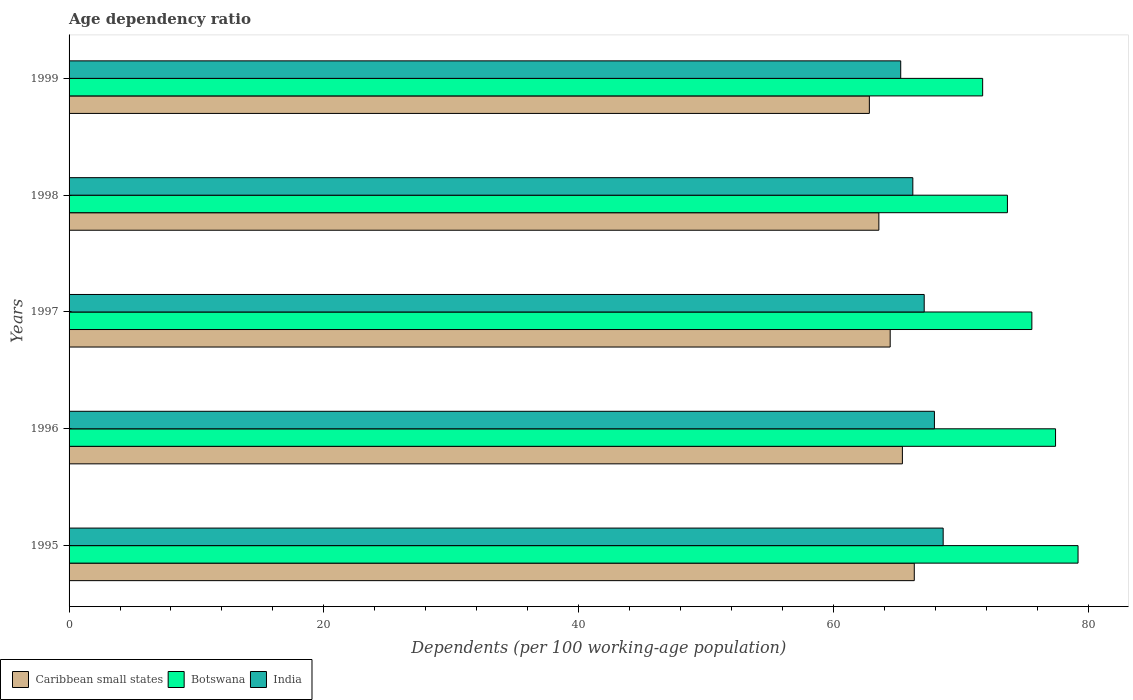How many groups of bars are there?
Keep it short and to the point. 5. Are the number of bars per tick equal to the number of legend labels?
Keep it short and to the point. Yes. What is the label of the 5th group of bars from the top?
Make the answer very short. 1995. In how many cases, is the number of bars for a given year not equal to the number of legend labels?
Provide a succinct answer. 0. What is the age dependency ratio in in Caribbean small states in 1997?
Your response must be concise. 64.46. Across all years, what is the maximum age dependency ratio in in Caribbean small states?
Offer a terse response. 66.36. Across all years, what is the minimum age dependency ratio in in Botswana?
Give a very brief answer. 71.72. In which year was the age dependency ratio in in India minimum?
Offer a terse response. 1999. What is the total age dependency ratio in in Botswana in the graph?
Provide a succinct answer. 377.64. What is the difference between the age dependency ratio in in Caribbean small states in 1995 and that in 1997?
Provide a short and direct response. 1.89. What is the difference between the age dependency ratio in in Caribbean small states in 1996 and the age dependency ratio in in Botswana in 1997?
Ensure brevity in your answer.  -10.16. What is the average age dependency ratio in in Botswana per year?
Your answer should be compact. 75.53. In the year 1998, what is the difference between the age dependency ratio in in Caribbean small states and age dependency ratio in in Botswana?
Ensure brevity in your answer.  -10.09. What is the ratio of the age dependency ratio in in Botswana in 1995 to that in 1999?
Provide a succinct answer. 1.1. Is the age dependency ratio in in Caribbean small states in 1995 less than that in 1997?
Offer a terse response. No. Is the difference between the age dependency ratio in in Caribbean small states in 1995 and 1998 greater than the difference between the age dependency ratio in in Botswana in 1995 and 1998?
Keep it short and to the point. No. What is the difference between the highest and the second highest age dependency ratio in in Botswana?
Your response must be concise. 1.77. What is the difference between the highest and the lowest age dependency ratio in in Botswana?
Keep it short and to the point. 7.49. What does the 1st bar from the top in 1996 represents?
Make the answer very short. India. What does the 3rd bar from the bottom in 1996 represents?
Provide a succinct answer. India. Is it the case that in every year, the sum of the age dependency ratio in in Caribbean small states and age dependency ratio in in Botswana is greater than the age dependency ratio in in India?
Give a very brief answer. Yes. How many bars are there?
Offer a very short reply. 15. How many years are there in the graph?
Provide a short and direct response. 5. What is the difference between two consecutive major ticks on the X-axis?
Your answer should be compact. 20. Are the values on the major ticks of X-axis written in scientific E-notation?
Your response must be concise. No. Does the graph contain any zero values?
Ensure brevity in your answer.  No. Where does the legend appear in the graph?
Offer a very short reply. Bottom left. How many legend labels are there?
Your answer should be very brief. 3. How are the legend labels stacked?
Your response must be concise. Horizontal. What is the title of the graph?
Give a very brief answer. Age dependency ratio. Does "Uzbekistan" appear as one of the legend labels in the graph?
Provide a succinct answer. No. What is the label or title of the X-axis?
Provide a short and direct response. Dependents (per 100 working-age population). What is the Dependents (per 100 working-age population) of Caribbean small states in 1995?
Your response must be concise. 66.36. What is the Dependents (per 100 working-age population) of Botswana in 1995?
Keep it short and to the point. 79.21. What is the Dependents (per 100 working-age population) in India in 1995?
Offer a very short reply. 68.62. What is the Dependents (per 100 working-age population) in Caribbean small states in 1996?
Keep it short and to the point. 65.42. What is the Dependents (per 100 working-age population) in Botswana in 1996?
Offer a very short reply. 77.45. What is the Dependents (per 100 working-age population) of India in 1996?
Offer a very short reply. 67.94. What is the Dependents (per 100 working-age population) in Caribbean small states in 1997?
Your answer should be very brief. 64.46. What is the Dependents (per 100 working-age population) in Botswana in 1997?
Your answer should be compact. 75.59. What is the Dependents (per 100 working-age population) of India in 1997?
Your answer should be very brief. 67.13. What is the Dependents (per 100 working-age population) of Caribbean small states in 1998?
Offer a very short reply. 63.57. What is the Dependents (per 100 working-age population) in Botswana in 1998?
Offer a very short reply. 73.67. What is the Dependents (per 100 working-age population) in India in 1998?
Your response must be concise. 66.24. What is the Dependents (per 100 working-age population) of Caribbean small states in 1999?
Provide a short and direct response. 62.83. What is the Dependents (per 100 working-age population) of Botswana in 1999?
Make the answer very short. 71.72. What is the Dependents (per 100 working-age population) of India in 1999?
Keep it short and to the point. 65.29. Across all years, what is the maximum Dependents (per 100 working-age population) of Caribbean small states?
Give a very brief answer. 66.36. Across all years, what is the maximum Dependents (per 100 working-age population) of Botswana?
Provide a succinct answer. 79.21. Across all years, what is the maximum Dependents (per 100 working-age population) of India?
Make the answer very short. 68.62. Across all years, what is the minimum Dependents (per 100 working-age population) of Caribbean small states?
Offer a terse response. 62.83. Across all years, what is the minimum Dependents (per 100 working-age population) of Botswana?
Offer a very short reply. 71.72. Across all years, what is the minimum Dependents (per 100 working-age population) in India?
Offer a terse response. 65.29. What is the total Dependents (per 100 working-age population) of Caribbean small states in the graph?
Ensure brevity in your answer.  322.64. What is the total Dependents (per 100 working-age population) in Botswana in the graph?
Your answer should be very brief. 377.64. What is the total Dependents (per 100 working-age population) in India in the graph?
Make the answer very short. 335.23. What is the difference between the Dependents (per 100 working-age population) of Caribbean small states in 1995 and that in 1996?
Your answer should be compact. 0.93. What is the difference between the Dependents (per 100 working-age population) of Botswana in 1995 and that in 1996?
Provide a short and direct response. 1.77. What is the difference between the Dependents (per 100 working-age population) in India in 1995 and that in 1996?
Give a very brief answer. 0.69. What is the difference between the Dependents (per 100 working-age population) in Caribbean small states in 1995 and that in 1997?
Ensure brevity in your answer.  1.89. What is the difference between the Dependents (per 100 working-age population) of Botswana in 1995 and that in 1997?
Your answer should be compact. 3.63. What is the difference between the Dependents (per 100 working-age population) in India in 1995 and that in 1997?
Offer a terse response. 1.49. What is the difference between the Dependents (per 100 working-age population) in Caribbean small states in 1995 and that in 1998?
Make the answer very short. 2.78. What is the difference between the Dependents (per 100 working-age population) in Botswana in 1995 and that in 1998?
Provide a succinct answer. 5.54. What is the difference between the Dependents (per 100 working-age population) of India in 1995 and that in 1998?
Keep it short and to the point. 2.38. What is the difference between the Dependents (per 100 working-age population) of Caribbean small states in 1995 and that in 1999?
Your response must be concise. 3.53. What is the difference between the Dependents (per 100 working-age population) of Botswana in 1995 and that in 1999?
Provide a short and direct response. 7.49. What is the difference between the Dependents (per 100 working-age population) in India in 1995 and that in 1999?
Provide a succinct answer. 3.33. What is the difference between the Dependents (per 100 working-age population) in Caribbean small states in 1996 and that in 1997?
Offer a terse response. 0.96. What is the difference between the Dependents (per 100 working-age population) in Botswana in 1996 and that in 1997?
Provide a succinct answer. 1.86. What is the difference between the Dependents (per 100 working-age population) in India in 1996 and that in 1997?
Keep it short and to the point. 0.8. What is the difference between the Dependents (per 100 working-age population) of Caribbean small states in 1996 and that in 1998?
Make the answer very short. 1.85. What is the difference between the Dependents (per 100 working-age population) in Botswana in 1996 and that in 1998?
Your response must be concise. 3.78. What is the difference between the Dependents (per 100 working-age population) in India in 1996 and that in 1998?
Offer a very short reply. 1.7. What is the difference between the Dependents (per 100 working-age population) of Caribbean small states in 1996 and that in 1999?
Ensure brevity in your answer.  2.59. What is the difference between the Dependents (per 100 working-age population) in Botswana in 1996 and that in 1999?
Offer a very short reply. 5.72. What is the difference between the Dependents (per 100 working-age population) in India in 1996 and that in 1999?
Offer a very short reply. 2.65. What is the difference between the Dependents (per 100 working-age population) in Caribbean small states in 1997 and that in 1998?
Ensure brevity in your answer.  0.89. What is the difference between the Dependents (per 100 working-age population) of Botswana in 1997 and that in 1998?
Offer a very short reply. 1.92. What is the difference between the Dependents (per 100 working-age population) in India in 1997 and that in 1998?
Provide a short and direct response. 0.89. What is the difference between the Dependents (per 100 working-age population) in Caribbean small states in 1997 and that in 1999?
Provide a short and direct response. 1.64. What is the difference between the Dependents (per 100 working-age population) in Botswana in 1997 and that in 1999?
Offer a very short reply. 3.86. What is the difference between the Dependents (per 100 working-age population) in India in 1997 and that in 1999?
Provide a succinct answer. 1.84. What is the difference between the Dependents (per 100 working-age population) in Caribbean small states in 1998 and that in 1999?
Your answer should be compact. 0.75. What is the difference between the Dependents (per 100 working-age population) of Botswana in 1998 and that in 1999?
Provide a short and direct response. 1.94. What is the difference between the Dependents (per 100 working-age population) of India in 1998 and that in 1999?
Provide a succinct answer. 0.95. What is the difference between the Dependents (per 100 working-age population) in Caribbean small states in 1995 and the Dependents (per 100 working-age population) in Botswana in 1996?
Your answer should be very brief. -11.09. What is the difference between the Dependents (per 100 working-age population) in Caribbean small states in 1995 and the Dependents (per 100 working-age population) in India in 1996?
Ensure brevity in your answer.  -1.58. What is the difference between the Dependents (per 100 working-age population) of Botswana in 1995 and the Dependents (per 100 working-age population) of India in 1996?
Ensure brevity in your answer.  11.28. What is the difference between the Dependents (per 100 working-age population) of Caribbean small states in 1995 and the Dependents (per 100 working-age population) of Botswana in 1997?
Your response must be concise. -9.23. What is the difference between the Dependents (per 100 working-age population) in Caribbean small states in 1995 and the Dependents (per 100 working-age population) in India in 1997?
Keep it short and to the point. -0.78. What is the difference between the Dependents (per 100 working-age population) in Botswana in 1995 and the Dependents (per 100 working-age population) in India in 1997?
Provide a succinct answer. 12.08. What is the difference between the Dependents (per 100 working-age population) in Caribbean small states in 1995 and the Dependents (per 100 working-age population) in Botswana in 1998?
Your answer should be very brief. -7.31. What is the difference between the Dependents (per 100 working-age population) in Caribbean small states in 1995 and the Dependents (per 100 working-age population) in India in 1998?
Your answer should be very brief. 0.11. What is the difference between the Dependents (per 100 working-age population) of Botswana in 1995 and the Dependents (per 100 working-age population) of India in 1998?
Provide a succinct answer. 12.97. What is the difference between the Dependents (per 100 working-age population) in Caribbean small states in 1995 and the Dependents (per 100 working-age population) in Botswana in 1999?
Your answer should be very brief. -5.37. What is the difference between the Dependents (per 100 working-age population) of Caribbean small states in 1995 and the Dependents (per 100 working-age population) of India in 1999?
Make the answer very short. 1.07. What is the difference between the Dependents (per 100 working-age population) in Botswana in 1995 and the Dependents (per 100 working-age population) in India in 1999?
Your answer should be very brief. 13.92. What is the difference between the Dependents (per 100 working-age population) in Caribbean small states in 1996 and the Dependents (per 100 working-age population) in Botswana in 1997?
Your response must be concise. -10.16. What is the difference between the Dependents (per 100 working-age population) in Caribbean small states in 1996 and the Dependents (per 100 working-age population) in India in 1997?
Offer a terse response. -1.71. What is the difference between the Dependents (per 100 working-age population) in Botswana in 1996 and the Dependents (per 100 working-age population) in India in 1997?
Provide a short and direct response. 10.31. What is the difference between the Dependents (per 100 working-age population) in Caribbean small states in 1996 and the Dependents (per 100 working-age population) in Botswana in 1998?
Ensure brevity in your answer.  -8.25. What is the difference between the Dependents (per 100 working-age population) in Caribbean small states in 1996 and the Dependents (per 100 working-age population) in India in 1998?
Make the answer very short. -0.82. What is the difference between the Dependents (per 100 working-age population) in Botswana in 1996 and the Dependents (per 100 working-age population) in India in 1998?
Keep it short and to the point. 11.21. What is the difference between the Dependents (per 100 working-age population) of Caribbean small states in 1996 and the Dependents (per 100 working-age population) of Botswana in 1999?
Your response must be concise. -6.3. What is the difference between the Dependents (per 100 working-age population) in Caribbean small states in 1996 and the Dependents (per 100 working-age population) in India in 1999?
Provide a short and direct response. 0.13. What is the difference between the Dependents (per 100 working-age population) in Botswana in 1996 and the Dependents (per 100 working-age population) in India in 1999?
Your answer should be compact. 12.16. What is the difference between the Dependents (per 100 working-age population) of Caribbean small states in 1997 and the Dependents (per 100 working-age population) of Botswana in 1998?
Offer a very short reply. -9.2. What is the difference between the Dependents (per 100 working-age population) in Caribbean small states in 1997 and the Dependents (per 100 working-age population) in India in 1998?
Make the answer very short. -1.78. What is the difference between the Dependents (per 100 working-age population) of Botswana in 1997 and the Dependents (per 100 working-age population) of India in 1998?
Keep it short and to the point. 9.35. What is the difference between the Dependents (per 100 working-age population) of Caribbean small states in 1997 and the Dependents (per 100 working-age population) of Botswana in 1999?
Your response must be concise. -7.26. What is the difference between the Dependents (per 100 working-age population) of Caribbean small states in 1997 and the Dependents (per 100 working-age population) of India in 1999?
Keep it short and to the point. -0.83. What is the difference between the Dependents (per 100 working-age population) of Botswana in 1997 and the Dependents (per 100 working-age population) of India in 1999?
Offer a very short reply. 10.3. What is the difference between the Dependents (per 100 working-age population) in Caribbean small states in 1998 and the Dependents (per 100 working-age population) in Botswana in 1999?
Your response must be concise. -8.15. What is the difference between the Dependents (per 100 working-age population) in Caribbean small states in 1998 and the Dependents (per 100 working-age population) in India in 1999?
Ensure brevity in your answer.  -1.72. What is the difference between the Dependents (per 100 working-age population) in Botswana in 1998 and the Dependents (per 100 working-age population) in India in 1999?
Provide a succinct answer. 8.38. What is the average Dependents (per 100 working-age population) in Caribbean small states per year?
Your response must be concise. 64.53. What is the average Dependents (per 100 working-age population) in Botswana per year?
Ensure brevity in your answer.  75.53. What is the average Dependents (per 100 working-age population) in India per year?
Make the answer very short. 67.05. In the year 1995, what is the difference between the Dependents (per 100 working-age population) of Caribbean small states and Dependents (per 100 working-age population) of Botswana?
Provide a short and direct response. -12.86. In the year 1995, what is the difference between the Dependents (per 100 working-age population) in Caribbean small states and Dependents (per 100 working-age population) in India?
Provide a succinct answer. -2.27. In the year 1995, what is the difference between the Dependents (per 100 working-age population) in Botswana and Dependents (per 100 working-age population) in India?
Give a very brief answer. 10.59. In the year 1996, what is the difference between the Dependents (per 100 working-age population) in Caribbean small states and Dependents (per 100 working-age population) in Botswana?
Your response must be concise. -12.02. In the year 1996, what is the difference between the Dependents (per 100 working-age population) in Caribbean small states and Dependents (per 100 working-age population) in India?
Make the answer very short. -2.51. In the year 1996, what is the difference between the Dependents (per 100 working-age population) in Botswana and Dependents (per 100 working-age population) in India?
Make the answer very short. 9.51. In the year 1997, what is the difference between the Dependents (per 100 working-age population) of Caribbean small states and Dependents (per 100 working-age population) of Botswana?
Ensure brevity in your answer.  -11.12. In the year 1997, what is the difference between the Dependents (per 100 working-age population) of Caribbean small states and Dependents (per 100 working-age population) of India?
Your answer should be very brief. -2.67. In the year 1997, what is the difference between the Dependents (per 100 working-age population) of Botswana and Dependents (per 100 working-age population) of India?
Your answer should be very brief. 8.45. In the year 1998, what is the difference between the Dependents (per 100 working-age population) in Caribbean small states and Dependents (per 100 working-age population) in Botswana?
Ensure brevity in your answer.  -10.09. In the year 1998, what is the difference between the Dependents (per 100 working-age population) of Caribbean small states and Dependents (per 100 working-age population) of India?
Your answer should be very brief. -2.67. In the year 1998, what is the difference between the Dependents (per 100 working-age population) of Botswana and Dependents (per 100 working-age population) of India?
Your answer should be very brief. 7.43. In the year 1999, what is the difference between the Dependents (per 100 working-age population) of Caribbean small states and Dependents (per 100 working-age population) of Botswana?
Ensure brevity in your answer.  -8.9. In the year 1999, what is the difference between the Dependents (per 100 working-age population) in Caribbean small states and Dependents (per 100 working-age population) in India?
Your answer should be very brief. -2.46. In the year 1999, what is the difference between the Dependents (per 100 working-age population) of Botswana and Dependents (per 100 working-age population) of India?
Ensure brevity in your answer.  6.43. What is the ratio of the Dependents (per 100 working-age population) of Caribbean small states in 1995 to that in 1996?
Make the answer very short. 1.01. What is the ratio of the Dependents (per 100 working-age population) of Botswana in 1995 to that in 1996?
Keep it short and to the point. 1.02. What is the ratio of the Dependents (per 100 working-age population) in Caribbean small states in 1995 to that in 1997?
Provide a succinct answer. 1.03. What is the ratio of the Dependents (per 100 working-age population) of Botswana in 1995 to that in 1997?
Provide a succinct answer. 1.05. What is the ratio of the Dependents (per 100 working-age population) of India in 1995 to that in 1997?
Provide a short and direct response. 1.02. What is the ratio of the Dependents (per 100 working-age population) of Caribbean small states in 1995 to that in 1998?
Provide a short and direct response. 1.04. What is the ratio of the Dependents (per 100 working-age population) of Botswana in 1995 to that in 1998?
Your answer should be compact. 1.08. What is the ratio of the Dependents (per 100 working-age population) in India in 1995 to that in 1998?
Make the answer very short. 1.04. What is the ratio of the Dependents (per 100 working-age population) of Caribbean small states in 1995 to that in 1999?
Offer a terse response. 1.06. What is the ratio of the Dependents (per 100 working-age population) of Botswana in 1995 to that in 1999?
Offer a very short reply. 1.1. What is the ratio of the Dependents (per 100 working-age population) of India in 1995 to that in 1999?
Your answer should be very brief. 1.05. What is the ratio of the Dependents (per 100 working-age population) of Caribbean small states in 1996 to that in 1997?
Ensure brevity in your answer.  1.01. What is the ratio of the Dependents (per 100 working-age population) of Botswana in 1996 to that in 1997?
Provide a short and direct response. 1.02. What is the ratio of the Dependents (per 100 working-age population) of India in 1996 to that in 1997?
Give a very brief answer. 1.01. What is the ratio of the Dependents (per 100 working-age population) of Caribbean small states in 1996 to that in 1998?
Give a very brief answer. 1.03. What is the ratio of the Dependents (per 100 working-age population) in Botswana in 1996 to that in 1998?
Keep it short and to the point. 1.05. What is the ratio of the Dependents (per 100 working-age population) of India in 1996 to that in 1998?
Make the answer very short. 1.03. What is the ratio of the Dependents (per 100 working-age population) of Caribbean small states in 1996 to that in 1999?
Offer a terse response. 1.04. What is the ratio of the Dependents (per 100 working-age population) in Botswana in 1996 to that in 1999?
Make the answer very short. 1.08. What is the ratio of the Dependents (per 100 working-age population) of India in 1996 to that in 1999?
Make the answer very short. 1.04. What is the ratio of the Dependents (per 100 working-age population) of Botswana in 1997 to that in 1998?
Provide a short and direct response. 1.03. What is the ratio of the Dependents (per 100 working-age population) of India in 1997 to that in 1998?
Provide a succinct answer. 1.01. What is the ratio of the Dependents (per 100 working-age population) in Botswana in 1997 to that in 1999?
Make the answer very short. 1.05. What is the ratio of the Dependents (per 100 working-age population) of India in 1997 to that in 1999?
Your answer should be compact. 1.03. What is the ratio of the Dependents (per 100 working-age population) of Caribbean small states in 1998 to that in 1999?
Give a very brief answer. 1.01. What is the ratio of the Dependents (per 100 working-age population) in Botswana in 1998 to that in 1999?
Keep it short and to the point. 1.03. What is the ratio of the Dependents (per 100 working-age population) in India in 1998 to that in 1999?
Make the answer very short. 1.01. What is the difference between the highest and the second highest Dependents (per 100 working-age population) in Caribbean small states?
Your answer should be very brief. 0.93. What is the difference between the highest and the second highest Dependents (per 100 working-age population) of Botswana?
Ensure brevity in your answer.  1.77. What is the difference between the highest and the second highest Dependents (per 100 working-age population) of India?
Your answer should be very brief. 0.69. What is the difference between the highest and the lowest Dependents (per 100 working-age population) in Caribbean small states?
Give a very brief answer. 3.53. What is the difference between the highest and the lowest Dependents (per 100 working-age population) of Botswana?
Provide a short and direct response. 7.49. What is the difference between the highest and the lowest Dependents (per 100 working-age population) in India?
Give a very brief answer. 3.33. 